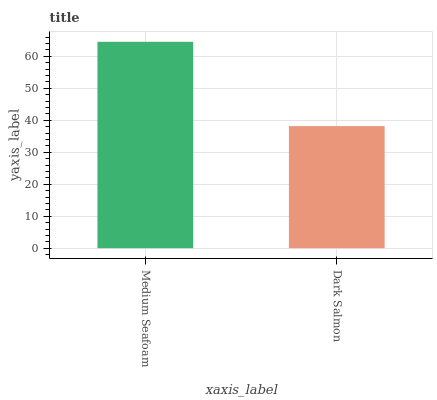Is Dark Salmon the minimum?
Answer yes or no. Yes. Is Medium Seafoam the maximum?
Answer yes or no. Yes. Is Dark Salmon the maximum?
Answer yes or no. No. Is Medium Seafoam greater than Dark Salmon?
Answer yes or no. Yes. Is Dark Salmon less than Medium Seafoam?
Answer yes or no. Yes. Is Dark Salmon greater than Medium Seafoam?
Answer yes or no. No. Is Medium Seafoam less than Dark Salmon?
Answer yes or no. No. Is Medium Seafoam the high median?
Answer yes or no. Yes. Is Dark Salmon the low median?
Answer yes or no. Yes. Is Dark Salmon the high median?
Answer yes or no. No. Is Medium Seafoam the low median?
Answer yes or no. No. 